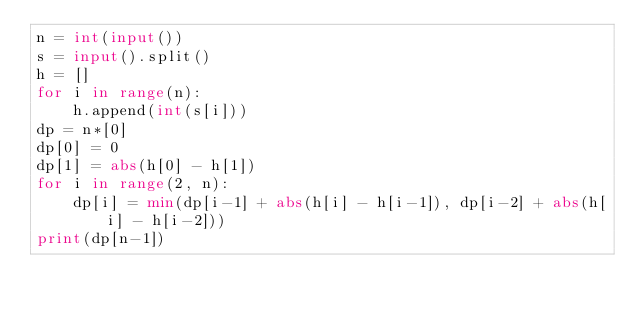Convert code to text. <code><loc_0><loc_0><loc_500><loc_500><_Python_>n = int(input())
s = input().split()
h = []
for i in range(n):
    h.append(int(s[i]))
dp = n*[0]
dp[0] = 0
dp[1] = abs(h[0] - h[1])
for i in range(2, n):
    dp[i] = min(dp[i-1] + abs(h[i] - h[i-1]), dp[i-2] + abs(h[i] - h[i-2]))
print(dp[n-1])
</code> 